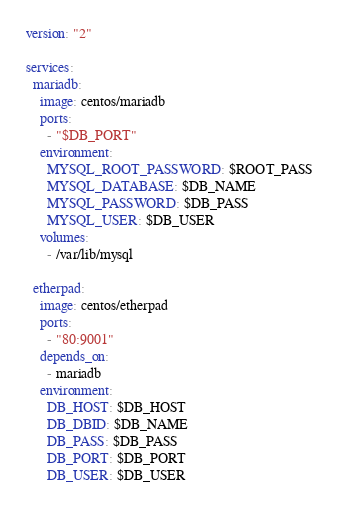<code> <loc_0><loc_0><loc_500><loc_500><_YAML_>version: "2"

services:
  mariadb:
    image: centos/mariadb
    ports:
      - "$DB_PORT"
    environment:
      MYSQL_ROOT_PASSWORD: $ROOT_PASS
      MYSQL_DATABASE: $DB_NAME
      MYSQL_PASSWORD: $DB_PASS
      MYSQL_USER: $DB_USER
    volumes:
      - /var/lib/mysql

  etherpad:
    image: centos/etherpad
    ports:
      - "80:9001"
    depends_on:
      - mariadb
    environment:
      DB_HOST: $DB_HOST
      DB_DBID: $DB_NAME
      DB_PASS: $DB_PASS
      DB_PORT: $DB_PORT
      DB_USER: $DB_USER
</code> 